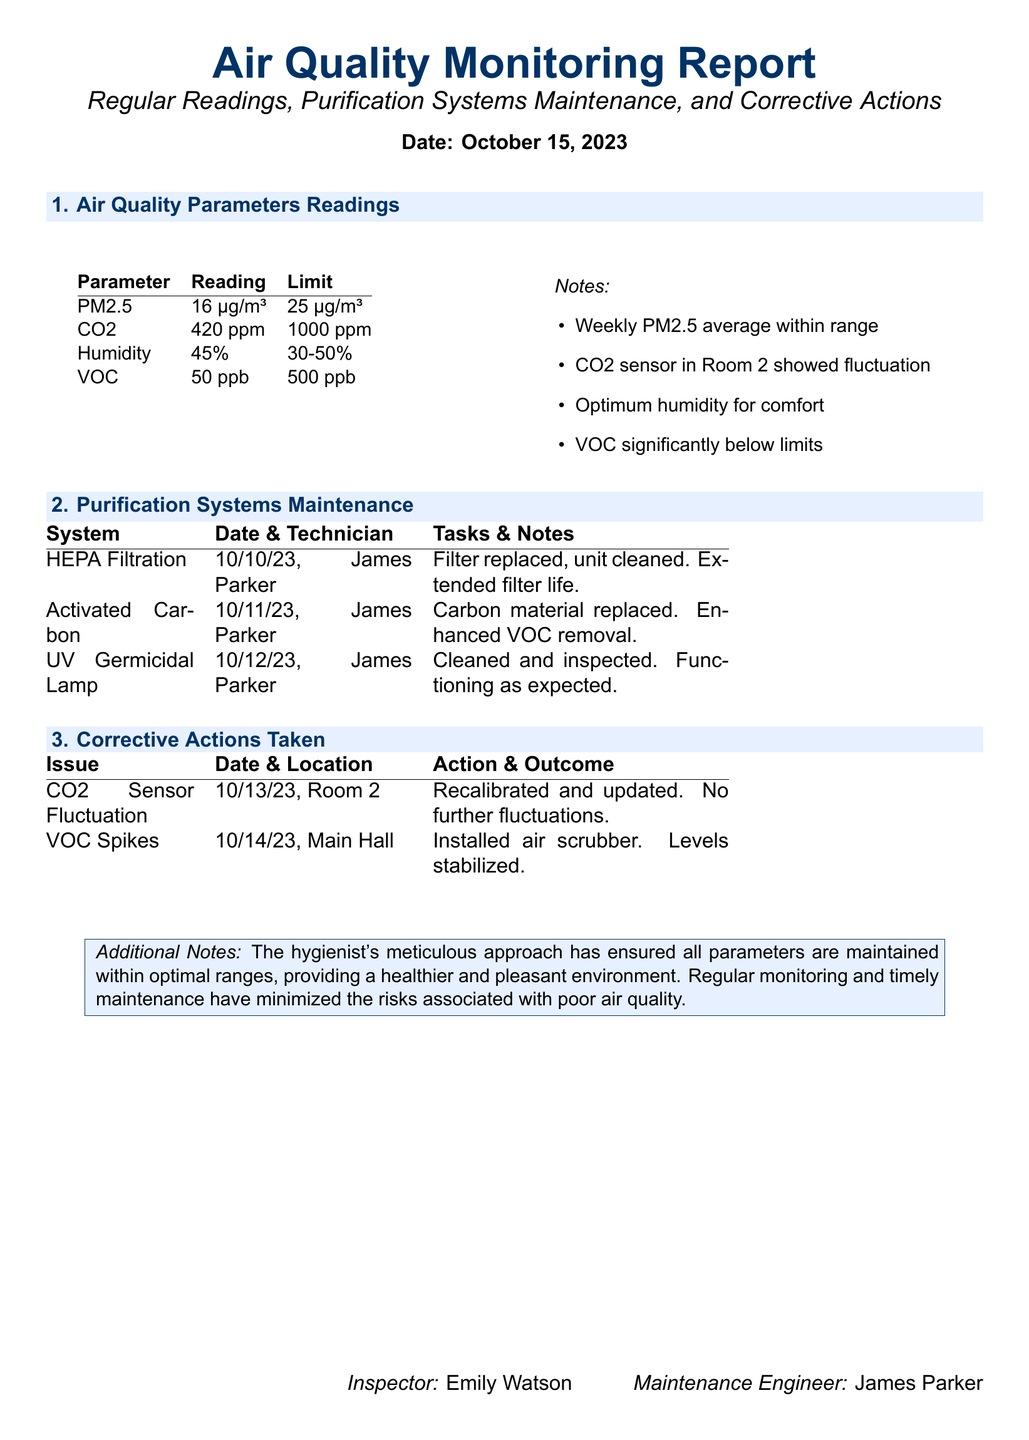what is the date of the report? The report is dated October 15, 2023.
Answer: October 15, 2023 who is the maintenance engineer mentioned in the document? The document lists James Parker as the maintenance engineer.
Answer: James Parker what is the PM2.5 reading? The PM2.5 reading is 16 µg/m³.
Answer: 16 µg/m³ what issue was addressed in Room 2? The issue addressed in Room 2 was CO2 sensor fluctuation.
Answer: CO2 sensor fluctuation how many purification systems were maintained according to the report? The report mentions three purification systems that were maintained.
Answer: three what corrective action was taken for VOC spikes? An air scrubber was installed to stabilize VOC levels.
Answer: Installed air scrubber when was the HEPA filtration system last maintained? The HEPA filtration system was last maintained on 10/10/23.
Answer: 10/10/23 what is the humidity reading recorded? The humidity reading recorded is 45%.
Answer: 45% which technician performed the maintenance on the UV Germicidal Lamp? James Parker performed the maintenance on the UV Germicidal Lamp.
Answer: James Parker 